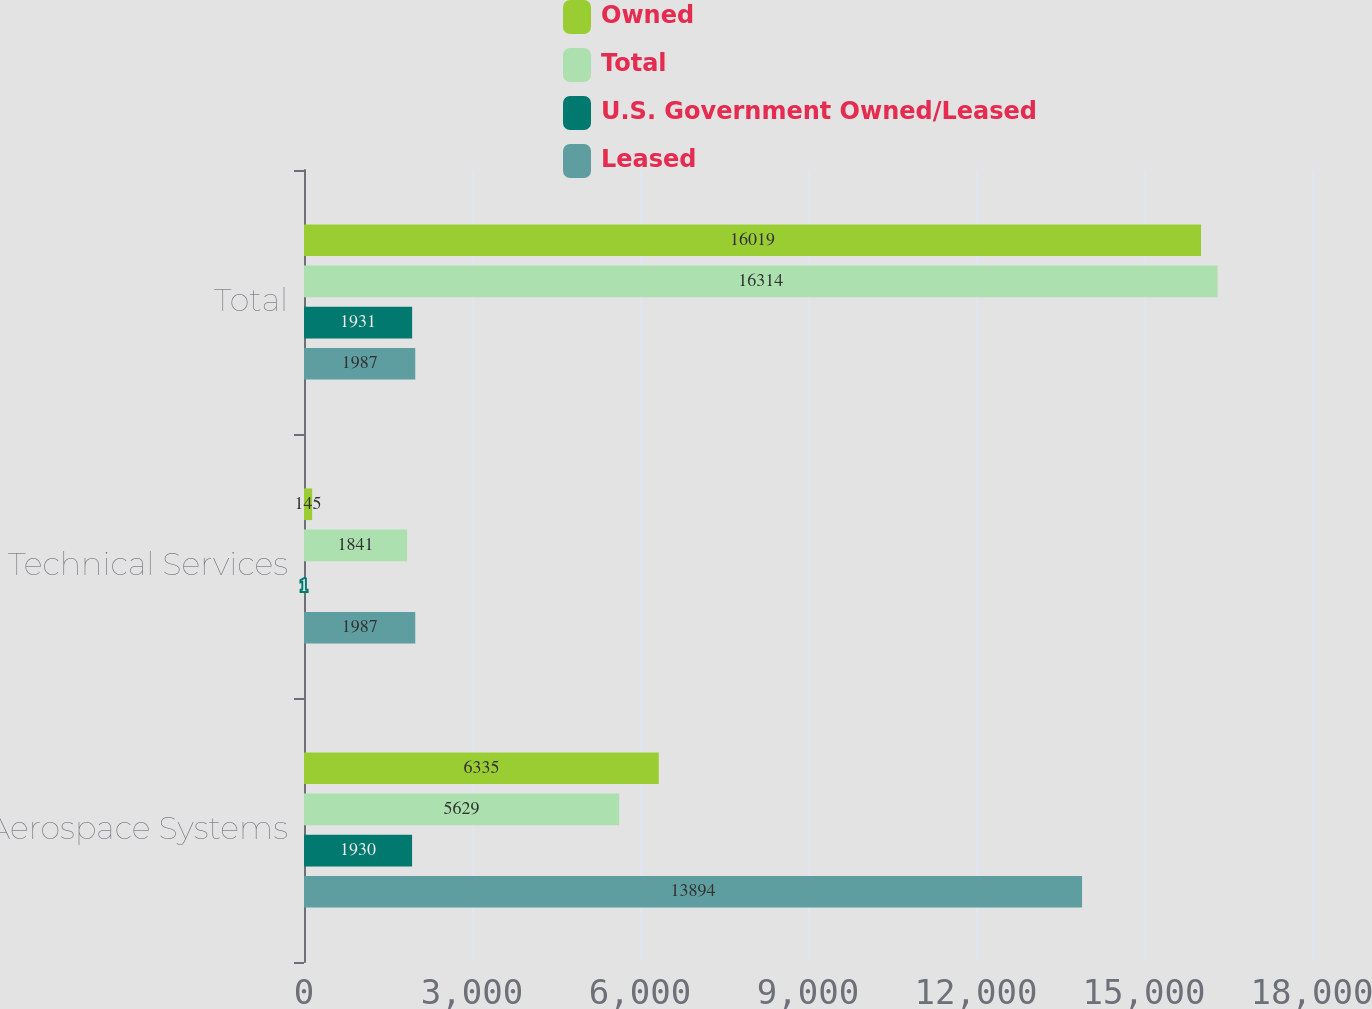Convert chart to OTSL. <chart><loc_0><loc_0><loc_500><loc_500><stacked_bar_chart><ecel><fcel>Aerospace Systems<fcel>Technical Services<fcel>Total<nl><fcel>Owned<fcel>6335<fcel>145<fcel>16019<nl><fcel>Total<fcel>5629<fcel>1841<fcel>16314<nl><fcel>U.S. Government Owned/Leased<fcel>1930<fcel>1<fcel>1931<nl><fcel>Leased<fcel>13894<fcel>1987<fcel>1987<nl></chart> 